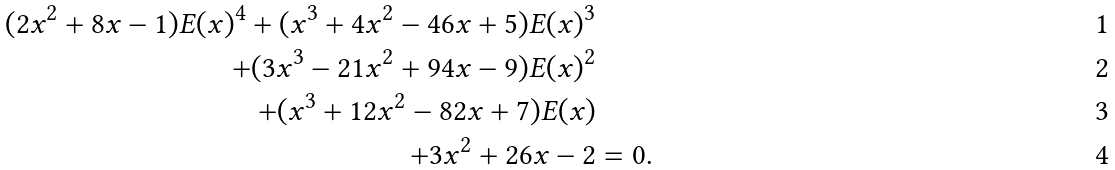<formula> <loc_0><loc_0><loc_500><loc_500>( 2 x ^ { 2 } + 8 x - 1 ) E ( x ) ^ { 4 } + ( x ^ { 3 } + 4 x ^ { 2 } - 4 6 x + 5 ) E ( x ) ^ { 3 } \\ + ( 3 x ^ { 3 } - 2 1 x ^ { 2 } + 9 4 x - 9 ) E ( x ) ^ { 2 } \\ + ( x ^ { 3 } + 1 2 x ^ { 2 } - 8 2 x + 7 ) E ( x ) \\ + 3 x ^ { 2 } + 2 6 x - 2 & = 0 .</formula> 